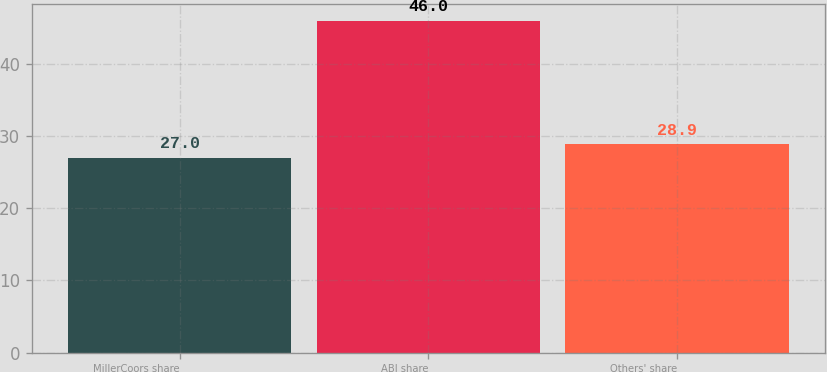<chart> <loc_0><loc_0><loc_500><loc_500><bar_chart><fcel>MillerCoors share<fcel>ABI share<fcel>Others' share<nl><fcel>27<fcel>46<fcel>28.9<nl></chart> 